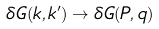<formula> <loc_0><loc_0><loc_500><loc_500>\delta G ( { k } , { k } ^ { \prime } ) \rightarrow \delta G ( { P } , { q } )</formula> 